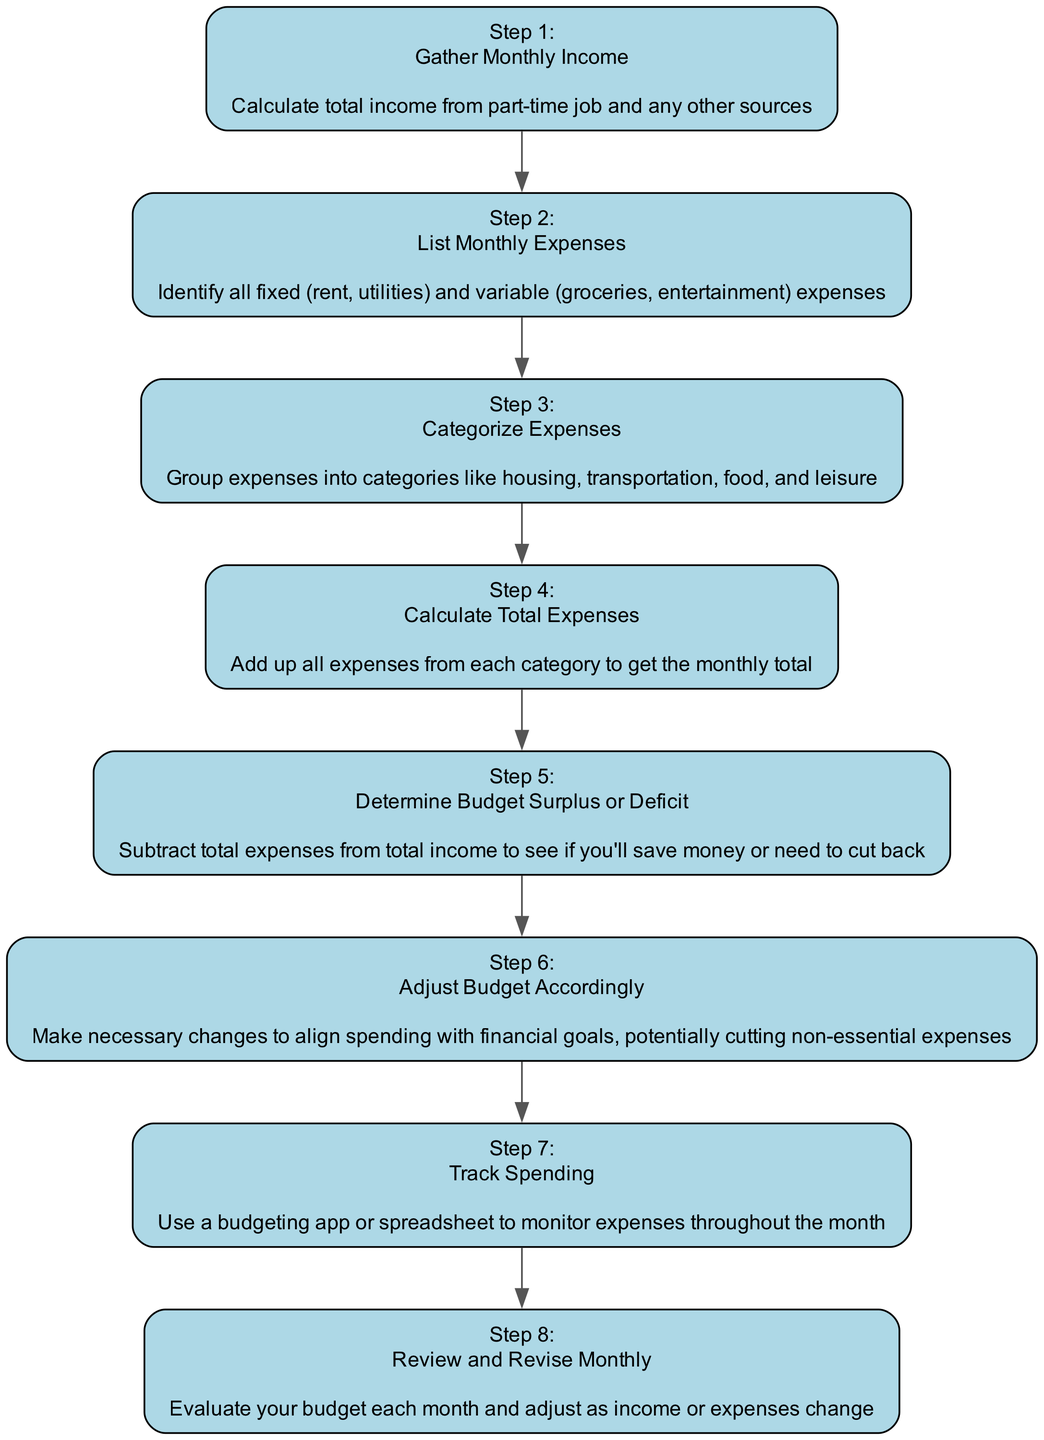What is the first step in the budget creation process? The first step in the flow chart is "Gather Monthly Income," which is clearly labeled as step 1. This action involves calculating the total income from various sources like a part-time job.
Answer: Gather Monthly Income How many steps are there in the diagram? By counting the entries in the diagram, we find there are 8 distinct steps outlined from 1 to 8. Each step corresponds to a specific action in creating a budget.
Answer: 8 What action follows 'Calculate Total Expenses'? The action that follows "Calculate Total Expenses," which is step 4, is "Determine Budget Surplus or Deficit," listed as step 5 in the diagram.
Answer: Determine Budget Surplus or Deficit Which step involves using a budgeting app? The step that involves using a budgeting app is "Track Spending," which is step 7 in the flow chart. This action emphasizes the need for monitoring expenses throughout the month.
Answer: Track Spending What is the last step in the budgeting process? The last step, as denoted in the diagram, is "Review and Revise Monthly," which is step 8. This entails evaluating the budget each month to make necessary adjustments.
Answer: Review and Revise Monthly What is the purpose of the 'Determine Budget Surplus or Deficit' step? The purpose of the 'Determine Budget Surplus or Deficit' step is to calculate whether the total income exceeds the total expenses, helping to identify if the individual can save money or needs to adjust spending.
Answer: To see if you'll save money or need to cut back Which steps relate to evaluating expenses? Steps 4, 5, and 8 relate to evaluating expenses. Step 4 involves calculating total expenses, step 5 determines the surplus or deficit, and step 8 focuses on reviewing and revising these expenses each month.
Answer: Steps 4, 5, and 8 How do you adjust your budget according to the flow chart? To adjust your budget according to the flow chart, you follow step 6, which states to "Adjust Budget Accordingly." This means making necessary changes to align your spending with financial goals.
Answer: Adjust Budget Accordingly 